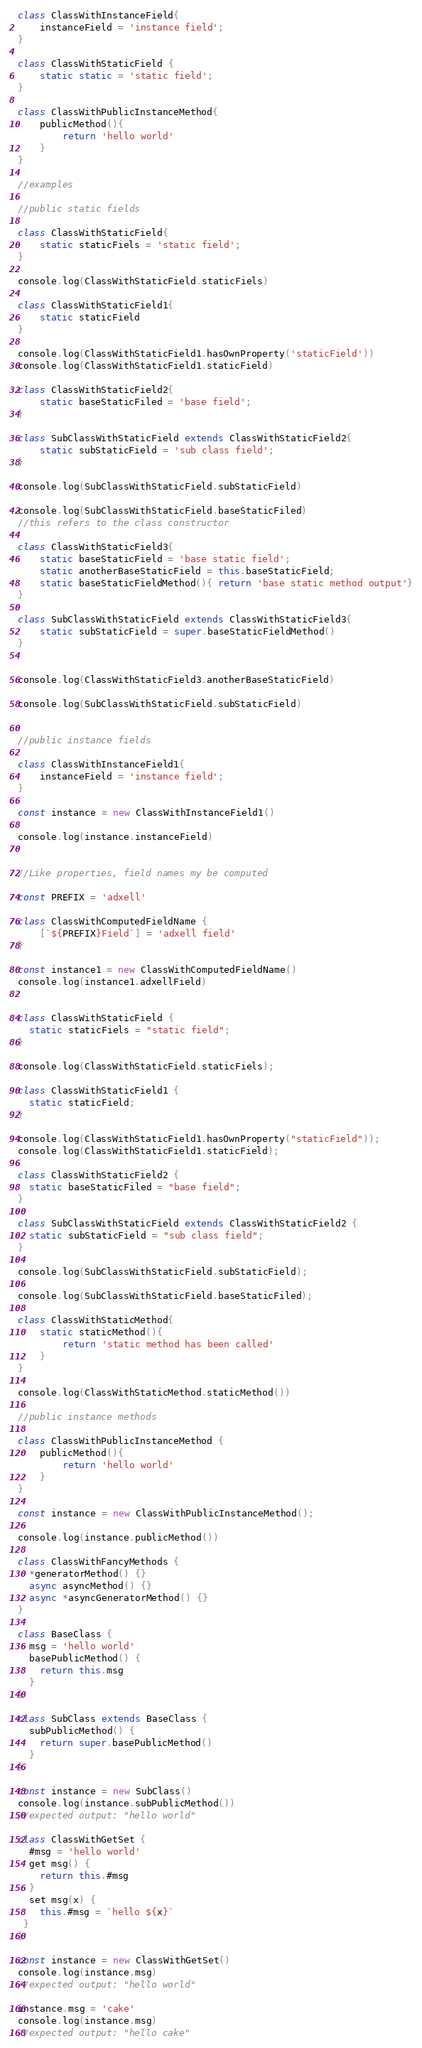<code> <loc_0><loc_0><loc_500><loc_500><_JavaScript_>class ClassWithInstanceField{
    instanceField = 'instance field';
}

class ClassWithStaticField {
    static static = 'static field';
}

class ClassWithPublicInstanceMethod{
    publicMethod(){
        return 'hello world'
    }
}

//examples 

//public static fields

class ClassWithStaticField{
    static staticFiels = 'static field';
}

console.log(ClassWithStaticField.staticFiels)

class ClassWithStaticField1{
    static staticField
}

console.log(ClassWithStaticField1.hasOwnProperty('staticField'))
console.log(ClassWithStaticField1.staticField)

class ClassWithStaticField2{
    static baseStaticFiled = 'base field';
}

class SubClassWithStaticField extends ClassWithStaticField2{
    static subStaticField = 'sub class field';
}

console.log(SubClassWithStaticField.subStaticField)

console.log(SubClassWithStaticField.baseStaticFiled)
//this refers to the class constructor

class ClassWithStaticField3{
    static baseStaticField = 'base static field';
    static anotherBaseStaticField = this.baseStaticField;
    static baseStaticFieldMethod(){ return 'base static method output'}
}

class SubClassWithStaticField extends ClassWithStaticField3{
    static subStaticField = super.baseStaticFieldMethod()
}


console.log(ClassWithStaticField3.anotherBaseStaticField)

console.log(SubClassWithStaticField.subStaticField)


//public instance fields 

class ClassWithInstanceField1{
    instanceField = 'instance field';
}

const instance = new ClassWithInstanceField1()

console.log(instance.instanceField)


//Like properties, field names my be computed 

const PREFIX = 'adxell'

class ClassWithComputedFieldName {
    [`${PREFIX}Field`] = 'adxell field'
}

const instance1 = new ClassWithComputedFieldName()
console.log(instance1.adxellField)


class ClassWithStaticField {
  static staticFiels = "static field";
}

console.log(ClassWithStaticField.staticFiels);

class ClassWithStaticField1 {
  static staticField;
}

console.log(ClassWithStaticField1.hasOwnProperty("staticField"));
console.log(ClassWithStaticField1.staticField);

class ClassWithStaticField2 {
  static baseStaticFiled = "base field";
}

class SubClassWithStaticField extends ClassWithStaticField2 {
  static subStaticField = "sub class field";
}

console.log(SubClassWithStaticField.subStaticField);

console.log(SubClassWithStaticField.baseStaticFiled);

class ClassWithStaticMethod{
    static staticMethod(){
        return 'static method has been called'
    }
}

console.log(ClassWithStaticMethod.staticMethod())

//public instance methods

class ClassWithPublicInstanceMethod {
    publicMethod(){
        return 'hello world'
    }
}

const instance = new ClassWithPublicInstanceMethod();

console.log(instance.publicMethod())

class ClassWithFancyMethods {
  *generatorMethod() {}
  async asyncMethod() {}
  async *asyncGeneratorMethod() {}
}

class BaseClass {
  msg = 'hello world'
  basePublicMethod() {
    return this.msg
  }
}

class SubClass extends BaseClass {
  subPublicMethod() {
    return super.basePublicMethod()
  }
}

const instance = new SubClass()
console.log(instance.subPublicMethod())
//expected output: "hello world"

class ClassWithGetSet {
  #msg = 'hello world'
  get msg() {
    return this.#msg
  }
  set msg(x) {
    this.#msg = `hello ${x}`
 }
}

const instance = new ClassWithGetSet()
console.log(instance.msg)
//expected output: "hello world"

instance.msg = 'cake'
console.log(instance.msg)
//expected output: "hello cake"</code> 